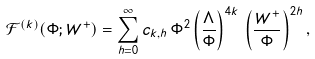Convert formula to latex. <formula><loc_0><loc_0><loc_500><loc_500>\mathcal { F } ^ { ( k ) } ( \Phi ; W ^ { + } ) = \sum _ { h = 0 } ^ { \infty } c _ { k , h } \, \Phi ^ { 2 } \left ( \frac { \Lambda } { \Phi } \right ) ^ { 4 k } \, \left ( \frac { W ^ { + } } { \Phi } \right ) ^ { 2 h } ,</formula> 